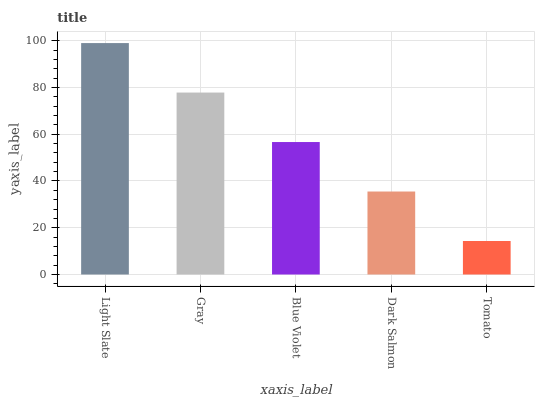Is Tomato the minimum?
Answer yes or no. Yes. Is Light Slate the maximum?
Answer yes or no. Yes. Is Gray the minimum?
Answer yes or no. No. Is Gray the maximum?
Answer yes or no. No. Is Light Slate greater than Gray?
Answer yes or no. Yes. Is Gray less than Light Slate?
Answer yes or no. Yes. Is Gray greater than Light Slate?
Answer yes or no. No. Is Light Slate less than Gray?
Answer yes or no. No. Is Blue Violet the high median?
Answer yes or no. Yes. Is Blue Violet the low median?
Answer yes or no. Yes. Is Dark Salmon the high median?
Answer yes or no. No. Is Tomato the low median?
Answer yes or no. No. 